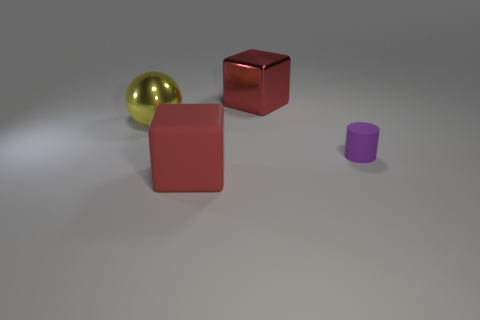Add 2 large objects. How many objects exist? 6 Add 4 large metal objects. How many large metal objects are left? 6 Add 2 metallic objects. How many metallic objects exist? 4 Subtract 0 cyan cylinders. How many objects are left? 4 Subtract all big yellow spheres. Subtract all large red matte blocks. How many objects are left? 2 